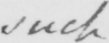What text is written in this handwritten line? such 